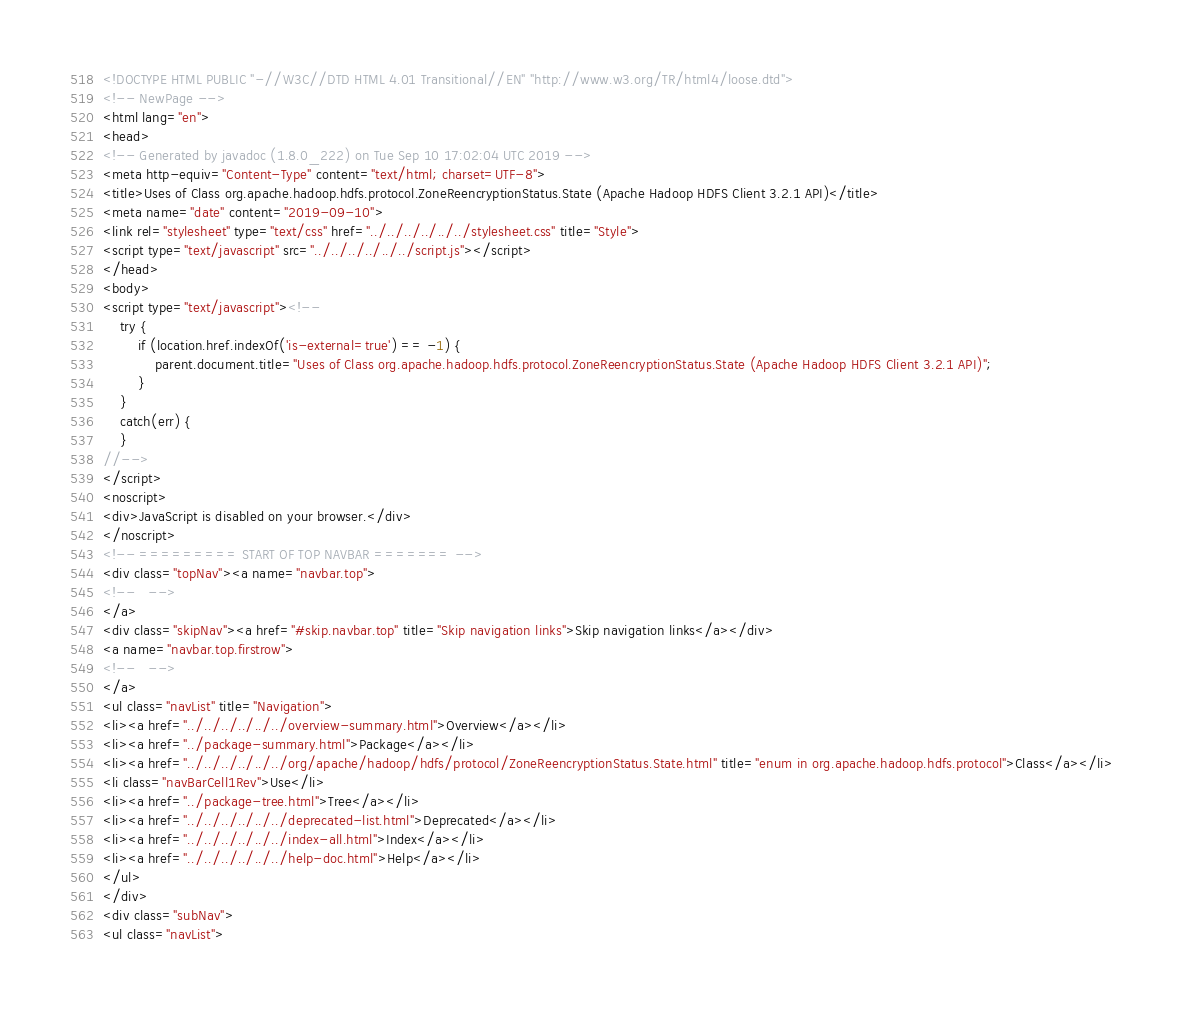<code> <loc_0><loc_0><loc_500><loc_500><_HTML_><!DOCTYPE HTML PUBLIC "-//W3C//DTD HTML 4.01 Transitional//EN" "http://www.w3.org/TR/html4/loose.dtd">
<!-- NewPage -->
<html lang="en">
<head>
<!-- Generated by javadoc (1.8.0_222) on Tue Sep 10 17:02:04 UTC 2019 -->
<meta http-equiv="Content-Type" content="text/html; charset=UTF-8">
<title>Uses of Class org.apache.hadoop.hdfs.protocol.ZoneReencryptionStatus.State (Apache Hadoop HDFS Client 3.2.1 API)</title>
<meta name="date" content="2019-09-10">
<link rel="stylesheet" type="text/css" href="../../../../../../stylesheet.css" title="Style">
<script type="text/javascript" src="../../../../../../script.js"></script>
</head>
<body>
<script type="text/javascript"><!--
    try {
        if (location.href.indexOf('is-external=true') == -1) {
            parent.document.title="Uses of Class org.apache.hadoop.hdfs.protocol.ZoneReencryptionStatus.State (Apache Hadoop HDFS Client 3.2.1 API)";
        }
    }
    catch(err) {
    }
//-->
</script>
<noscript>
<div>JavaScript is disabled on your browser.</div>
</noscript>
<!-- ========= START OF TOP NAVBAR ======= -->
<div class="topNav"><a name="navbar.top">
<!--   -->
</a>
<div class="skipNav"><a href="#skip.navbar.top" title="Skip navigation links">Skip navigation links</a></div>
<a name="navbar.top.firstrow">
<!--   -->
</a>
<ul class="navList" title="Navigation">
<li><a href="../../../../../../overview-summary.html">Overview</a></li>
<li><a href="../package-summary.html">Package</a></li>
<li><a href="../../../../../../org/apache/hadoop/hdfs/protocol/ZoneReencryptionStatus.State.html" title="enum in org.apache.hadoop.hdfs.protocol">Class</a></li>
<li class="navBarCell1Rev">Use</li>
<li><a href="../package-tree.html">Tree</a></li>
<li><a href="../../../../../../deprecated-list.html">Deprecated</a></li>
<li><a href="../../../../../../index-all.html">Index</a></li>
<li><a href="../../../../../../help-doc.html">Help</a></li>
</ul>
</div>
<div class="subNav">
<ul class="navList"></code> 